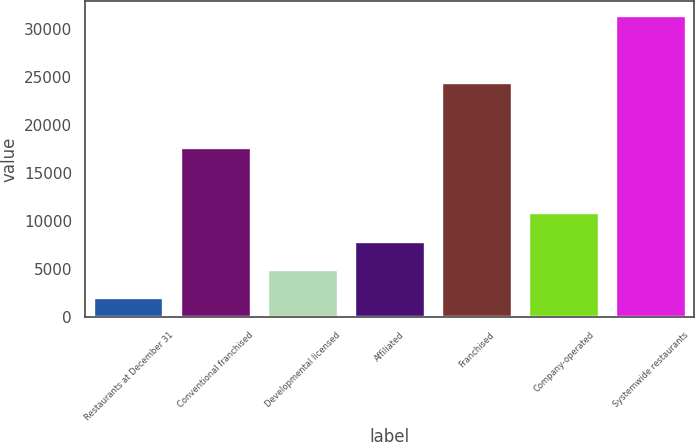Convert chart. <chart><loc_0><loc_0><loc_500><loc_500><bar_chart><fcel>Restaurants at December 31<fcel>Conventional franchised<fcel>Developmental licensed<fcel>Affiliated<fcel>Franchised<fcel>Company-operated<fcel>Systemwide restaurants<nl><fcel>2007<fcel>17634<fcel>4944<fcel>7881<fcel>24471<fcel>10818<fcel>31377<nl></chart> 